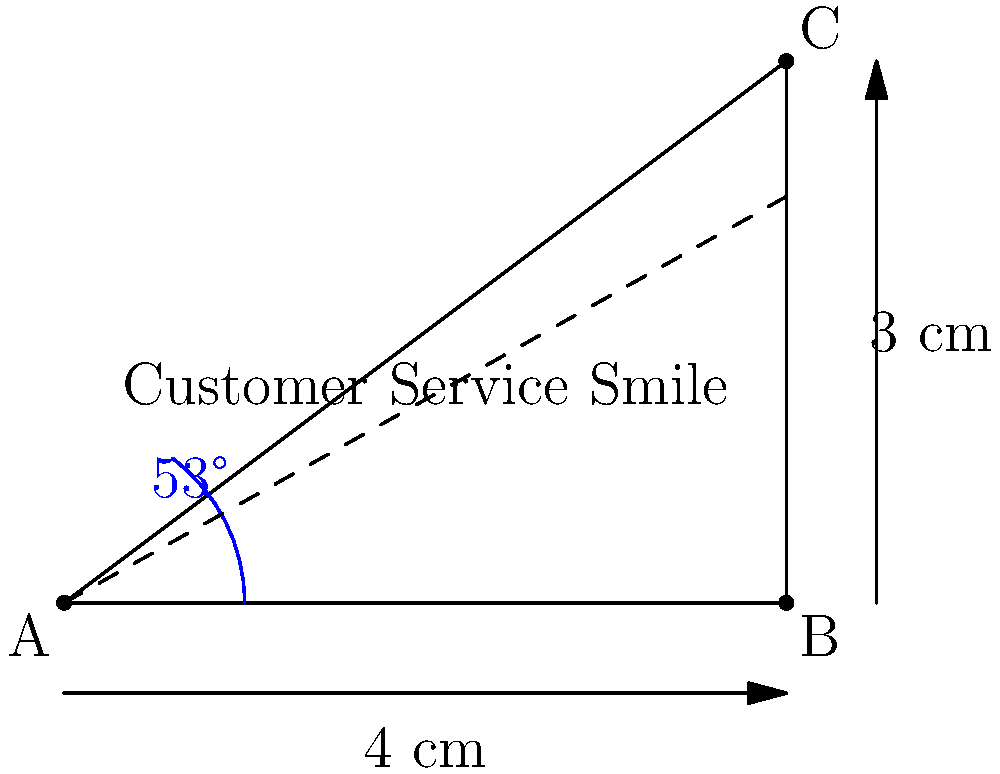As a store manager focused on customer service, you want to measure the "angle of a customer service smile" using a protractor. If the width of the smile is 4 cm and the height at its peak is 3 cm, what is the angle of the smile to the nearest degree? To find the angle of the customer service smile, we can use trigonometry. The smile forms a right triangle, where:

1. The base (width) of the triangle is 4 cm
2. The height of the triangle is 3 cm
3. We need to find the angle at the corner where the smile begins (point A in the diagram)

Let's solve this step-by-step:

1. In a right triangle, we can use the tangent function to find the angle:

   $\tan(\theta) = \frac{\text{opposite}}{\text{adjacent}} = \frac{\text{height}}{\text{width}}$

2. Plugging in our values:

   $\tan(\theta) = \frac{3}{4}$

3. To find the angle, we need to use the inverse tangent (arctan or $\tan^{-1}$):

   $\theta = \tan^{-1}(\frac{3}{4})$

4. Using a calculator or computer:

   $\theta \approx 36.87°$

5. Rounding to the nearest degree:

   $\theta \approx 37°$

6. The full angle of the smile would be twice this angle:

   $\text{Smile angle} = 2 \times 37° = 74°$

Therefore, the angle of the customer service smile is approximately 74°.
Answer: 74° 